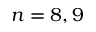Convert formula to latex. <formula><loc_0><loc_0><loc_500><loc_500>n = 8 , 9</formula> 